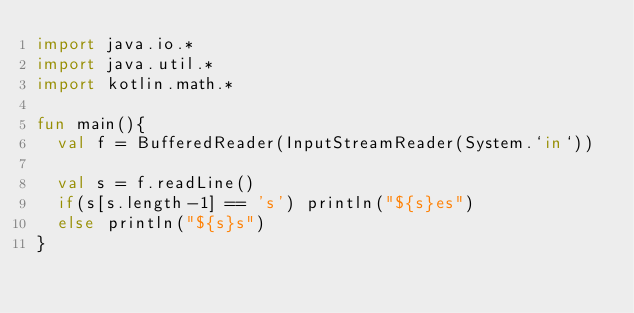<code> <loc_0><loc_0><loc_500><loc_500><_Kotlin_>import java.io.*
import java.util.*
import kotlin.math.*

fun main(){
	val f = BufferedReader(InputStreamReader(System.`in`))

	val s = f.readLine()
	if(s[s.length-1] == 's') println("${s}es")
	else println("${s}s")
}
</code> 